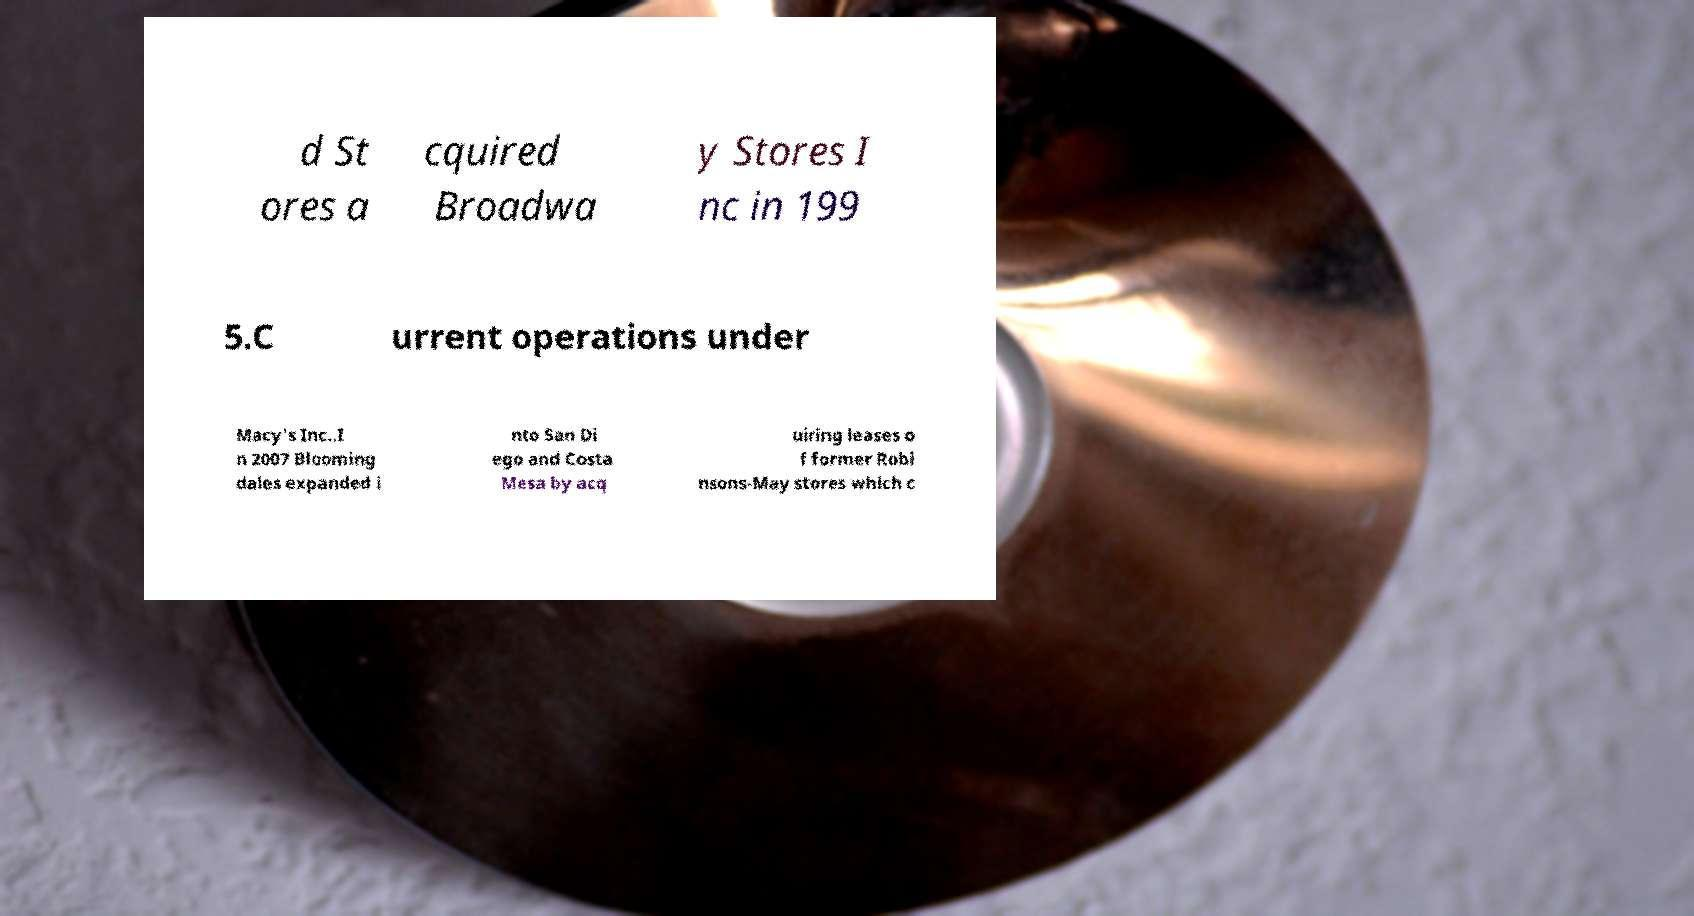There's text embedded in this image that I need extracted. Can you transcribe it verbatim? d St ores a cquired Broadwa y Stores I nc in 199 5.C urrent operations under Macy's Inc..I n 2007 Blooming dales expanded i nto San Di ego and Costa Mesa by acq uiring leases o f former Robi nsons-May stores which c 